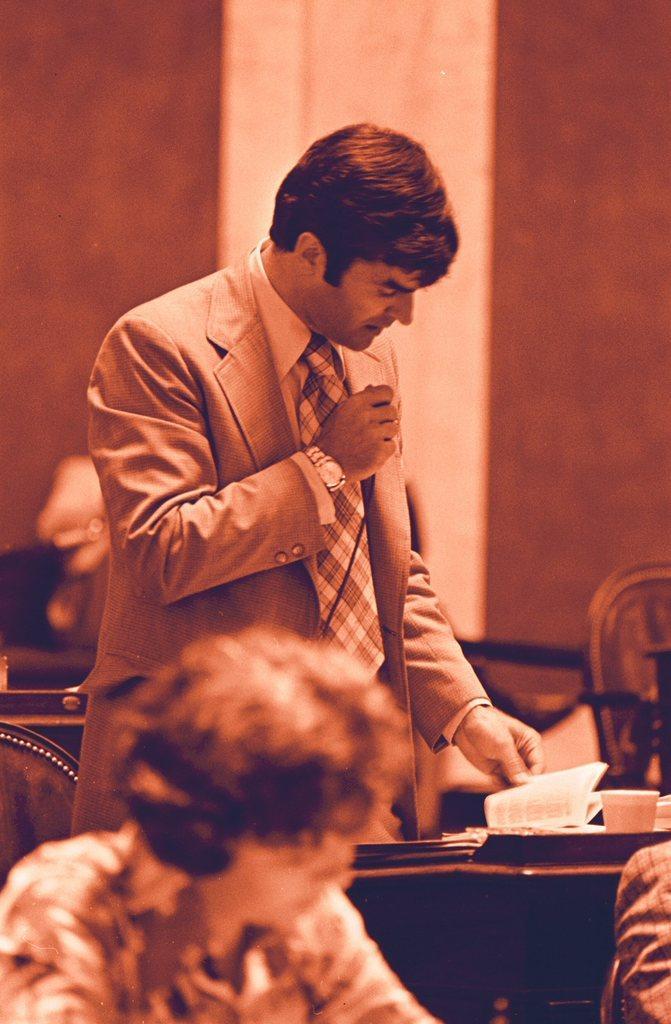In one or two sentences, can you explain what this image depicts? In this image we can see three persons, among them two persons are sitting and one person is standing and holding a mic, there are tables, on the tables, we can see a book, cup and some other objects, also we can see the chairs and in the background we can see the wall. 